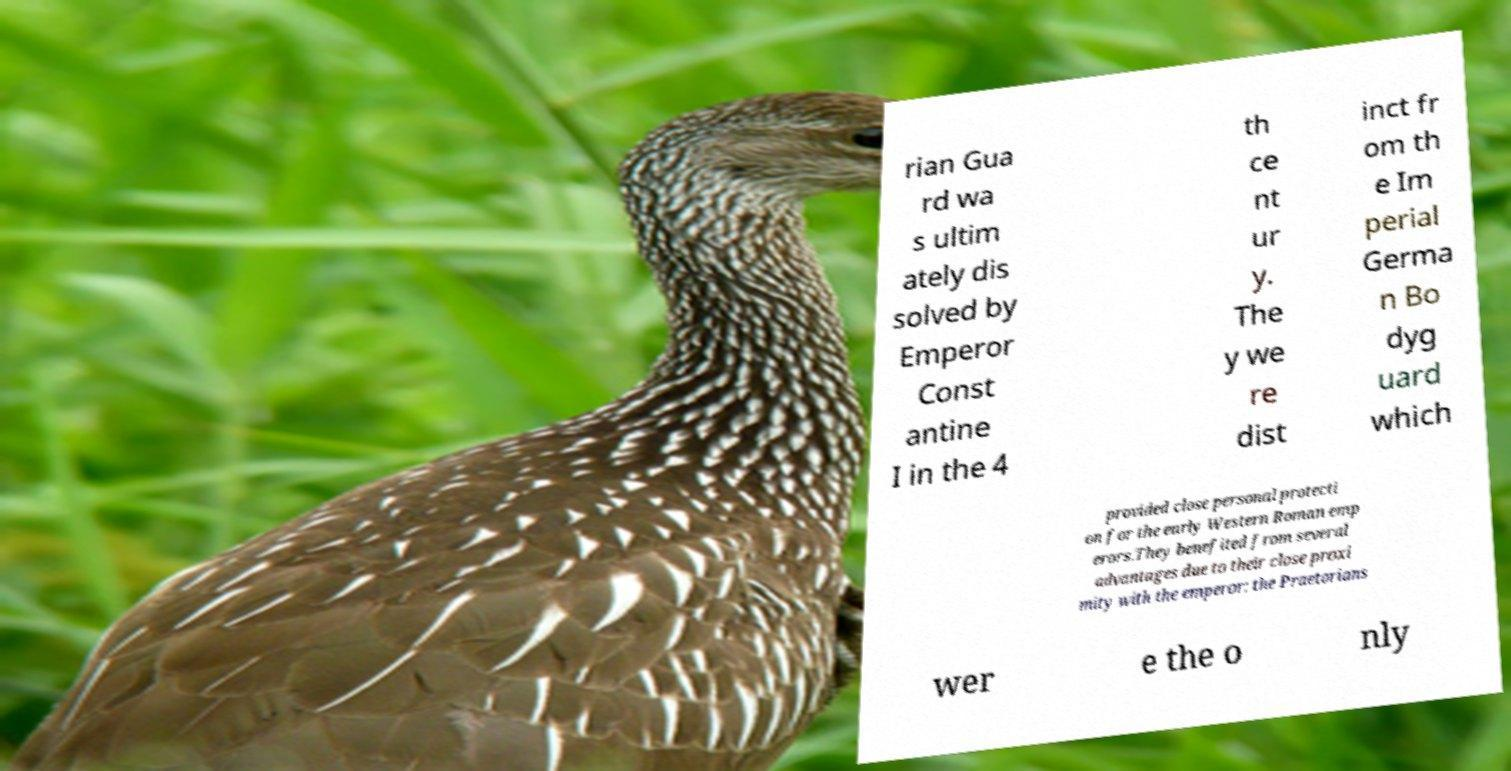For documentation purposes, I need the text within this image transcribed. Could you provide that? rian Gua rd wa s ultim ately dis solved by Emperor Const antine I in the 4 th ce nt ur y. The y we re dist inct fr om th e Im perial Germa n Bo dyg uard which provided close personal protecti on for the early Western Roman emp erors.They benefited from several advantages due to their close proxi mity with the emperor: the Praetorians wer e the o nly 